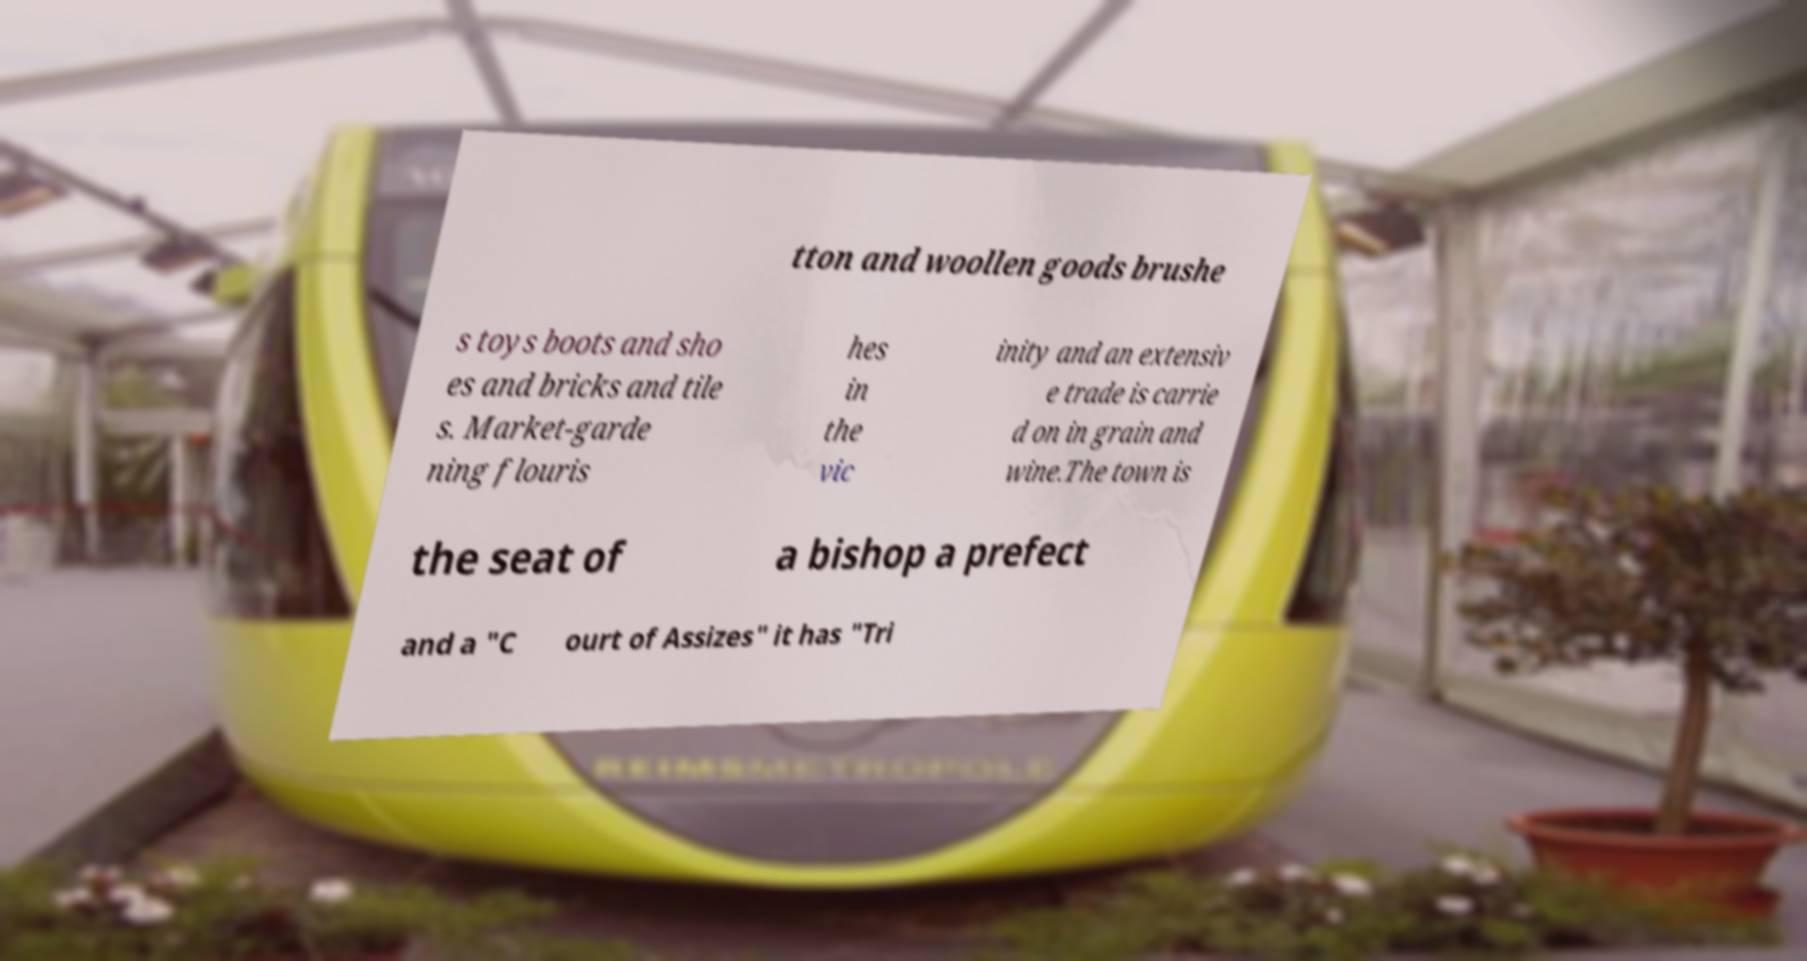I need the written content from this picture converted into text. Can you do that? tton and woollen goods brushe s toys boots and sho es and bricks and tile s. Market-garde ning flouris hes in the vic inity and an extensiv e trade is carrie d on in grain and wine.The town is the seat of a bishop a prefect and a "C ourt of Assizes" it has "Tri 